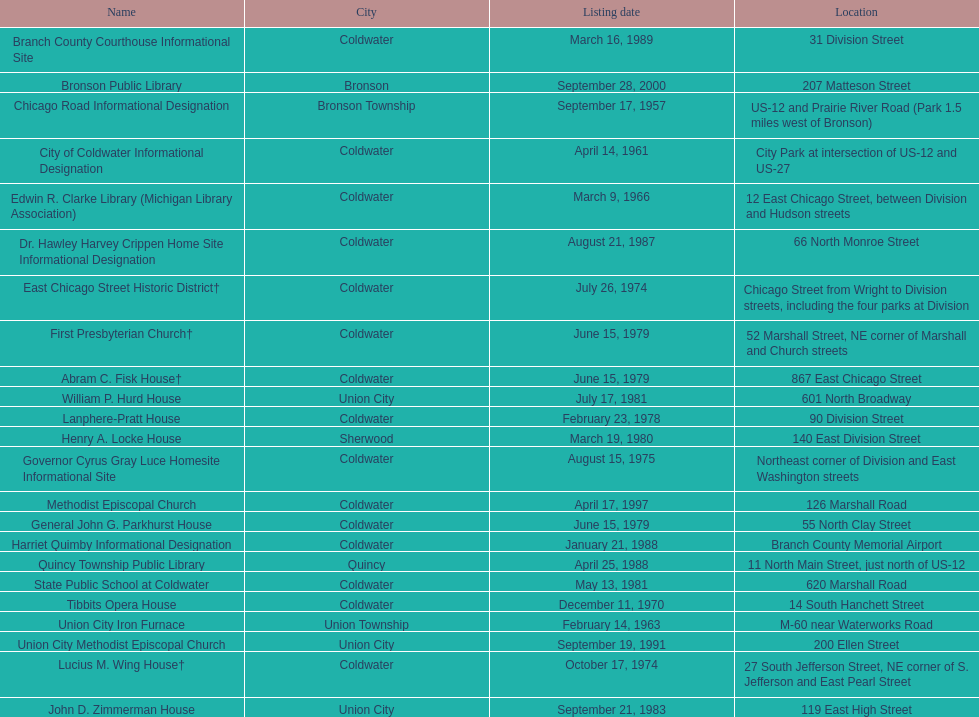How many years passed between the historic listing of public libraries in quincy and bronson? 12. 